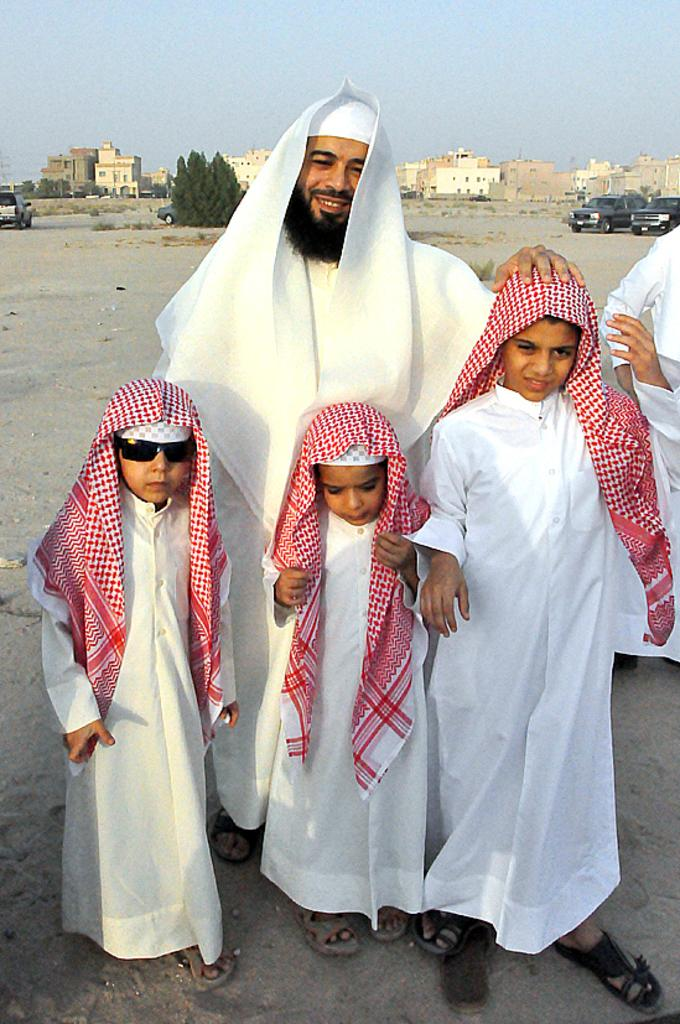Who is present in the image? There is a man and three kids in the image. What are the man and the kids doing in the image? The man and the kids are standing on the road. What type of brush can be seen in the image? There is no brush present in the image. Is the road on a slope in the image? The facts provided do not mention the slope of the road, so it cannot be determined from the image. 